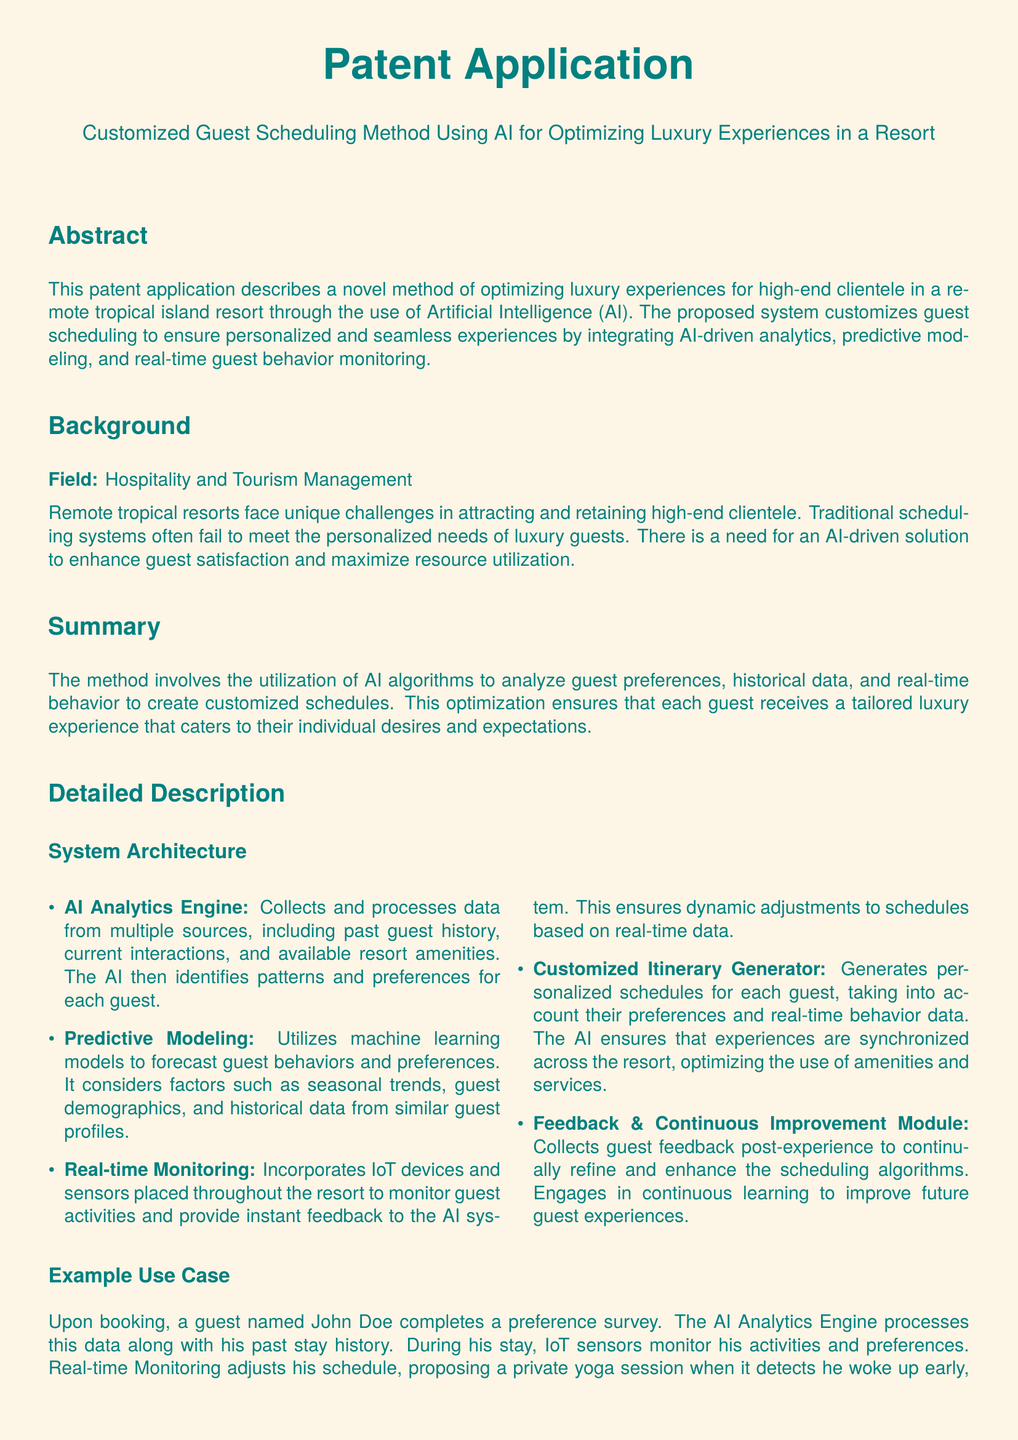What is the title of the patent application? The title of the patent application is provided in the document header, focusing on customized guest scheduling for luxury experiences in a resort.
Answer: Customized Guest Scheduling Method Using AI for Optimizing Luxury Experiences in a Resort What is the main technology used in the proposed method? The main technology highlighted in the document for optimizing luxury experiences is Artificial Intelligence (AI), as it plays a crucial role in guest scheduling.
Answer: Artificial Intelligence What does the AI Analytics Engine do? The document outlines that the AI Analytics Engine collects and processes data from multiple sources, which is vital for understanding guest preferences.
Answer: Collects and processes data What aspect does the Feedback & Continuous Improvement Module address? This module collects guest feedback post-experience to improve future scheduling algorithms, emphasizing the importance of continuous enhancement.
Answer: Refine scheduling algorithms How does Real-time Monitoring contribute to guest scheduling? Real-time Monitoring uses IoT devices to adjust guest schedules dynamically, ensuring that experiences can be tailored based on current activities.
Answer: Adjust schedules dynamically What was the name of the example guest used in the use case? The use case in the document features an example guest to showcase the method's functionality and personalization.
Answer: John Doe How many claims are listed in the patent? The document enumerates several distinct claims that describe the uniqueness and novelties of the scheduling method developed for luxury experiences.
Answer: Five What type of data does Predictive Modeling utilize? Predictive Modeling in the document takes into account factors such as seasonal trends and guest demographics to forecast preferences.
Answer: Seasonal trends, guest demographics What is the primary goal of the method described? The primary goal outlined in the document is to enhance guest satisfaction by personalizing their scheduling to meet individual desires and expectations.
Answer: Optimize luxury experiences 